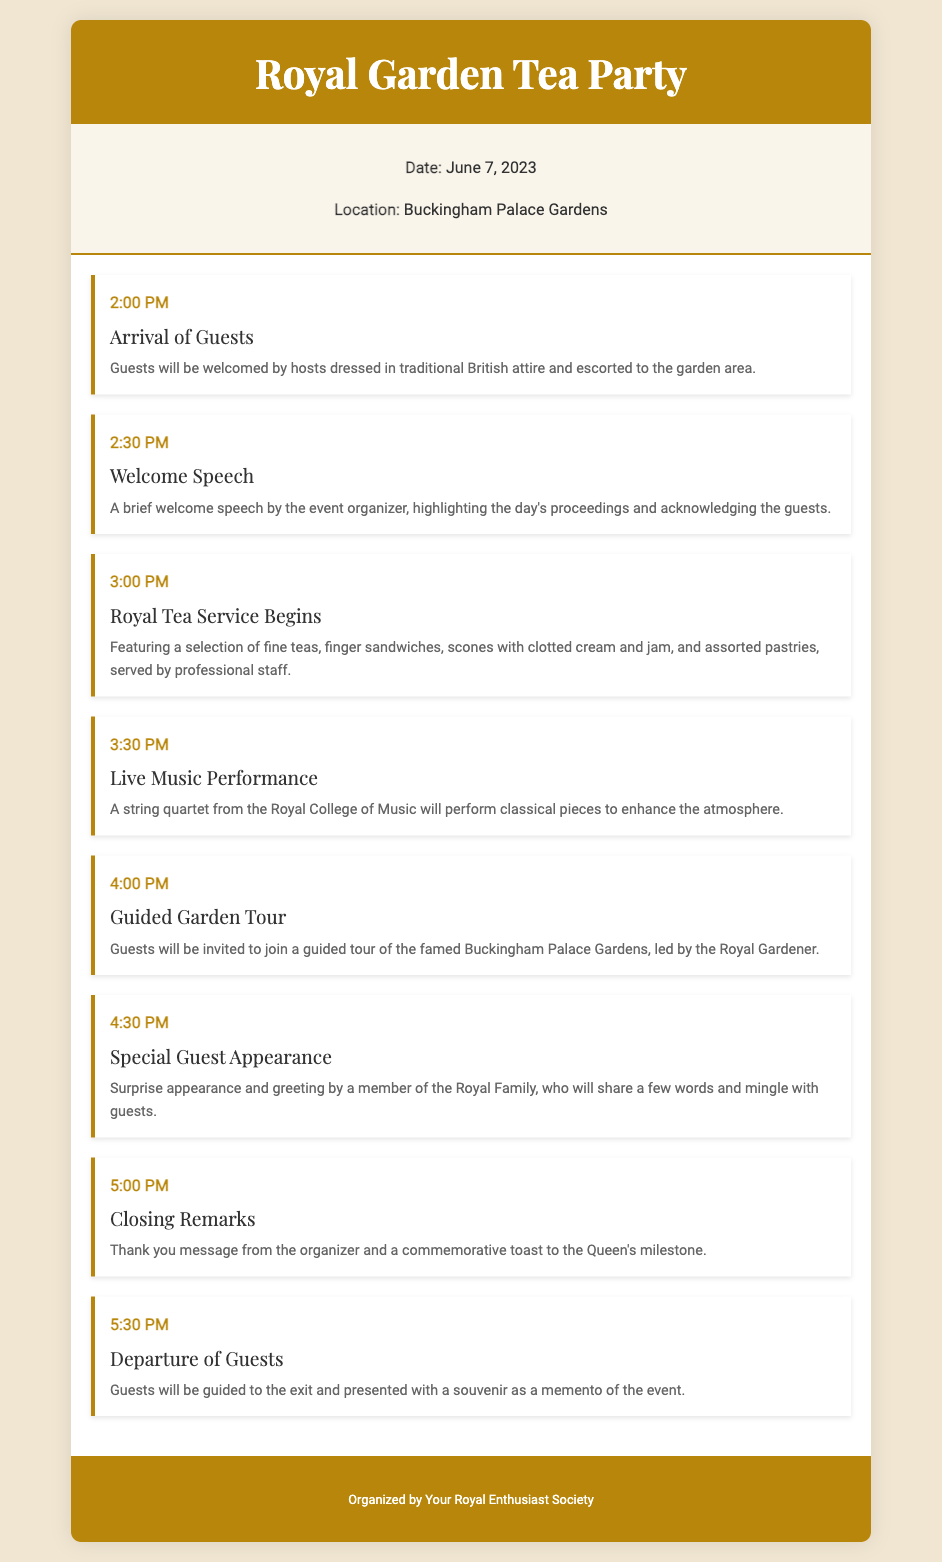What is the date of the Royal Garden Tea Party? The document states that the Royal Garden Tea Party will take place on June 7, 2023.
Answer: June 7, 2023 Where is the event located? The itinerary specifies that the location of the event is at Buckingham Palace Gardens.
Answer: Buckingham Palace Gardens What time do guests arrive? According to the itinerary, guests will arrive at 2:00 PM.
Answer: 2:00 PM What is the first activity scheduled? The first activity listed is the arrival of guests, starting at 2:00 PM.
Answer: Arrival of Guests Who will perform during the live music segment? The document mentions that a string quartet from the Royal College of Music will perform classical pieces.
Answer: String quartet from the Royal College of Music At what time is the special guest appearance scheduled? The itinerary indicates that the special guest appearance is set for 4:30 PM.
Answer: 4:30 PM What will guests receive upon departure? Guests will be presented with a souvenir as a memento of the event upon their departure.
Answer: A souvenir Who organized the event? The footer specifies that the event is organized by Your Royal Enthusiast Society.
Answer: Your Royal Enthusiast Society What type of food will be served during tea service? The document outlines that the royal tea service will feature fine teas, finger sandwiches, scones with clotted cream and jam, and assorted pastries.
Answer: Fine teas, finger sandwiches, scones, and assorted pastries 